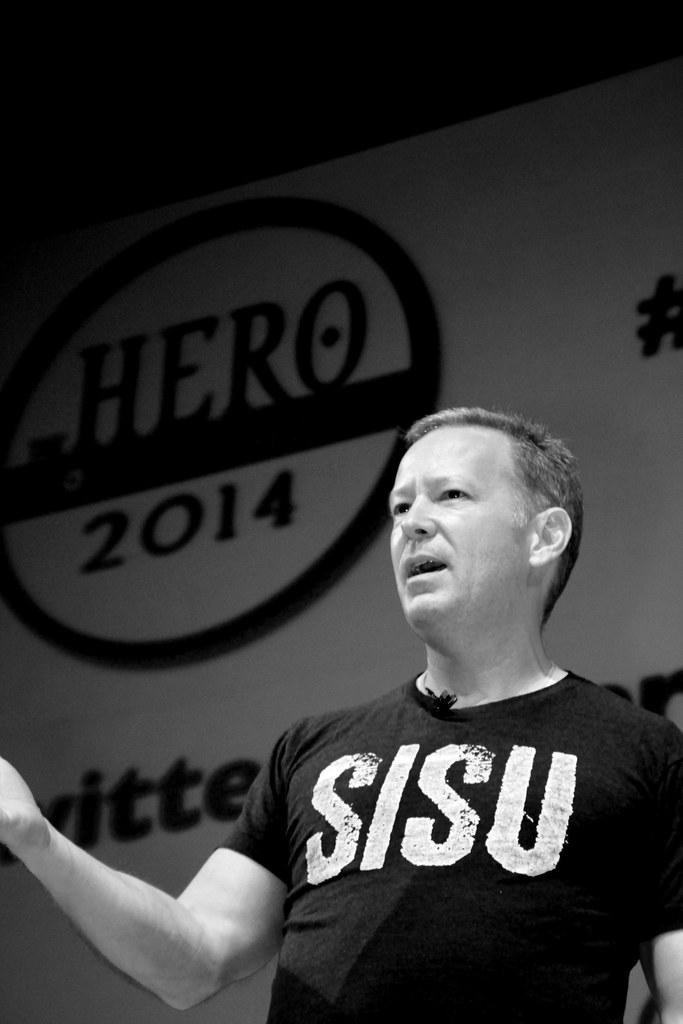<image>
Offer a succinct explanation of the picture presented. a shirt that has the letters SISU on it 